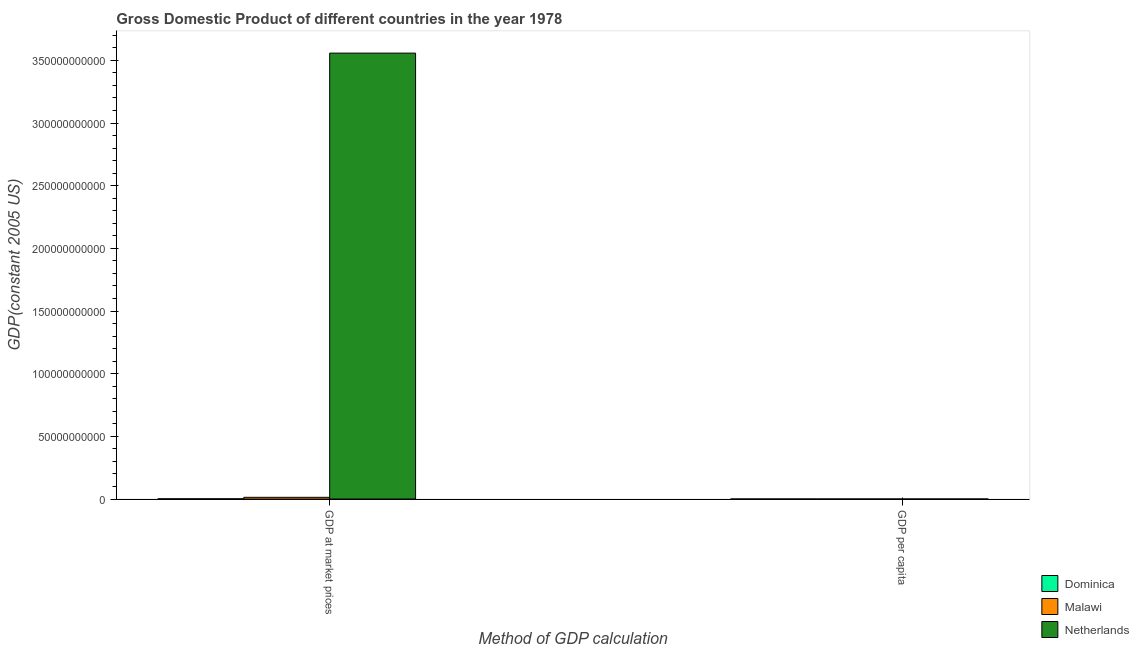How many different coloured bars are there?
Provide a short and direct response. 3. Are the number of bars on each tick of the X-axis equal?
Keep it short and to the point. Yes. How many bars are there on the 1st tick from the left?
Your response must be concise. 3. How many bars are there on the 2nd tick from the right?
Ensure brevity in your answer.  3. What is the label of the 2nd group of bars from the left?
Keep it short and to the point. GDP per capita. What is the gdp per capita in Malawi?
Offer a terse response. 236.07. Across all countries, what is the maximum gdp per capita?
Your answer should be very brief. 2.55e+04. Across all countries, what is the minimum gdp at market prices?
Provide a succinct answer. 1.81e+08. In which country was the gdp at market prices maximum?
Provide a short and direct response. Netherlands. In which country was the gdp per capita minimum?
Provide a short and direct response. Malawi. What is the total gdp at market prices in the graph?
Give a very brief answer. 3.57e+11. What is the difference between the gdp per capita in Netherlands and that in Dominica?
Make the answer very short. 2.31e+04. What is the difference between the gdp at market prices in Netherlands and the gdp per capita in Dominica?
Provide a short and direct response. 3.56e+11. What is the average gdp at market prices per country?
Provide a succinct answer. 1.19e+11. What is the difference between the gdp at market prices and gdp per capita in Malawi?
Provide a short and direct response. 1.37e+09. In how many countries, is the gdp per capita greater than 160000000000 US$?
Your answer should be compact. 0. What is the ratio of the gdp per capita in Malawi to that in Dominica?
Your response must be concise. 0.1. In how many countries, is the gdp at market prices greater than the average gdp at market prices taken over all countries?
Keep it short and to the point. 1. What does the 1st bar from the left in GDP per capita represents?
Your response must be concise. Dominica. What does the 1st bar from the right in GDP at market prices represents?
Keep it short and to the point. Netherlands. Are all the bars in the graph horizontal?
Offer a very short reply. No. How many countries are there in the graph?
Keep it short and to the point. 3. Are the values on the major ticks of Y-axis written in scientific E-notation?
Provide a succinct answer. No. Does the graph contain any zero values?
Give a very brief answer. No. Where does the legend appear in the graph?
Ensure brevity in your answer.  Bottom right. What is the title of the graph?
Your response must be concise. Gross Domestic Product of different countries in the year 1978. Does "Ukraine" appear as one of the legend labels in the graph?
Ensure brevity in your answer.  No. What is the label or title of the X-axis?
Your answer should be very brief. Method of GDP calculation. What is the label or title of the Y-axis?
Offer a very short reply. GDP(constant 2005 US). What is the GDP(constant 2005 US) of Dominica in GDP at market prices?
Ensure brevity in your answer.  1.81e+08. What is the GDP(constant 2005 US) of Malawi in GDP at market prices?
Provide a succinct answer. 1.37e+09. What is the GDP(constant 2005 US) in Netherlands in GDP at market prices?
Make the answer very short. 3.56e+11. What is the GDP(constant 2005 US) in Dominica in GDP per capita?
Make the answer very short. 2435.79. What is the GDP(constant 2005 US) in Malawi in GDP per capita?
Keep it short and to the point. 236.07. What is the GDP(constant 2005 US) of Netherlands in GDP per capita?
Offer a terse response. 2.55e+04. Across all Method of GDP calculation, what is the maximum GDP(constant 2005 US) of Dominica?
Offer a terse response. 1.81e+08. Across all Method of GDP calculation, what is the maximum GDP(constant 2005 US) in Malawi?
Make the answer very short. 1.37e+09. Across all Method of GDP calculation, what is the maximum GDP(constant 2005 US) of Netherlands?
Provide a short and direct response. 3.56e+11. Across all Method of GDP calculation, what is the minimum GDP(constant 2005 US) of Dominica?
Give a very brief answer. 2435.79. Across all Method of GDP calculation, what is the minimum GDP(constant 2005 US) in Malawi?
Keep it short and to the point. 236.07. Across all Method of GDP calculation, what is the minimum GDP(constant 2005 US) in Netherlands?
Offer a terse response. 2.55e+04. What is the total GDP(constant 2005 US) in Dominica in the graph?
Your response must be concise. 1.81e+08. What is the total GDP(constant 2005 US) of Malawi in the graph?
Your answer should be very brief. 1.37e+09. What is the total GDP(constant 2005 US) of Netherlands in the graph?
Ensure brevity in your answer.  3.56e+11. What is the difference between the GDP(constant 2005 US) of Dominica in GDP at market prices and that in GDP per capita?
Keep it short and to the point. 1.81e+08. What is the difference between the GDP(constant 2005 US) in Malawi in GDP at market prices and that in GDP per capita?
Give a very brief answer. 1.37e+09. What is the difference between the GDP(constant 2005 US) of Netherlands in GDP at market prices and that in GDP per capita?
Keep it short and to the point. 3.56e+11. What is the difference between the GDP(constant 2005 US) of Dominica in GDP at market prices and the GDP(constant 2005 US) of Malawi in GDP per capita?
Your response must be concise. 1.81e+08. What is the difference between the GDP(constant 2005 US) of Dominica in GDP at market prices and the GDP(constant 2005 US) of Netherlands in GDP per capita?
Make the answer very short. 1.81e+08. What is the difference between the GDP(constant 2005 US) in Malawi in GDP at market prices and the GDP(constant 2005 US) in Netherlands in GDP per capita?
Make the answer very short. 1.37e+09. What is the average GDP(constant 2005 US) of Dominica per Method of GDP calculation?
Give a very brief answer. 9.04e+07. What is the average GDP(constant 2005 US) of Malawi per Method of GDP calculation?
Provide a short and direct response. 6.85e+08. What is the average GDP(constant 2005 US) of Netherlands per Method of GDP calculation?
Provide a succinct answer. 1.78e+11. What is the difference between the GDP(constant 2005 US) in Dominica and GDP(constant 2005 US) in Malawi in GDP at market prices?
Provide a succinct answer. -1.19e+09. What is the difference between the GDP(constant 2005 US) in Dominica and GDP(constant 2005 US) in Netherlands in GDP at market prices?
Your answer should be very brief. -3.56e+11. What is the difference between the GDP(constant 2005 US) in Malawi and GDP(constant 2005 US) in Netherlands in GDP at market prices?
Give a very brief answer. -3.54e+11. What is the difference between the GDP(constant 2005 US) of Dominica and GDP(constant 2005 US) of Malawi in GDP per capita?
Provide a succinct answer. 2199.72. What is the difference between the GDP(constant 2005 US) of Dominica and GDP(constant 2005 US) of Netherlands in GDP per capita?
Provide a short and direct response. -2.31e+04. What is the difference between the GDP(constant 2005 US) of Malawi and GDP(constant 2005 US) of Netherlands in GDP per capita?
Give a very brief answer. -2.53e+04. What is the ratio of the GDP(constant 2005 US) of Dominica in GDP at market prices to that in GDP per capita?
Your answer should be compact. 7.42e+04. What is the ratio of the GDP(constant 2005 US) of Malawi in GDP at market prices to that in GDP per capita?
Make the answer very short. 5.81e+06. What is the ratio of the GDP(constant 2005 US) in Netherlands in GDP at market prices to that in GDP per capita?
Keep it short and to the point. 1.39e+07. What is the difference between the highest and the second highest GDP(constant 2005 US) in Dominica?
Provide a short and direct response. 1.81e+08. What is the difference between the highest and the second highest GDP(constant 2005 US) of Malawi?
Provide a short and direct response. 1.37e+09. What is the difference between the highest and the second highest GDP(constant 2005 US) in Netherlands?
Provide a short and direct response. 3.56e+11. What is the difference between the highest and the lowest GDP(constant 2005 US) in Dominica?
Make the answer very short. 1.81e+08. What is the difference between the highest and the lowest GDP(constant 2005 US) of Malawi?
Make the answer very short. 1.37e+09. What is the difference between the highest and the lowest GDP(constant 2005 US) in Netherlands?
Provide a short and direct response. 3.56e+11. 